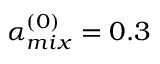<formula> <loc_0><loc_0><loc_500><loc_500>\alpha _ { m i x } ^ { ( 0 ) } = 0 . 3</formula> 